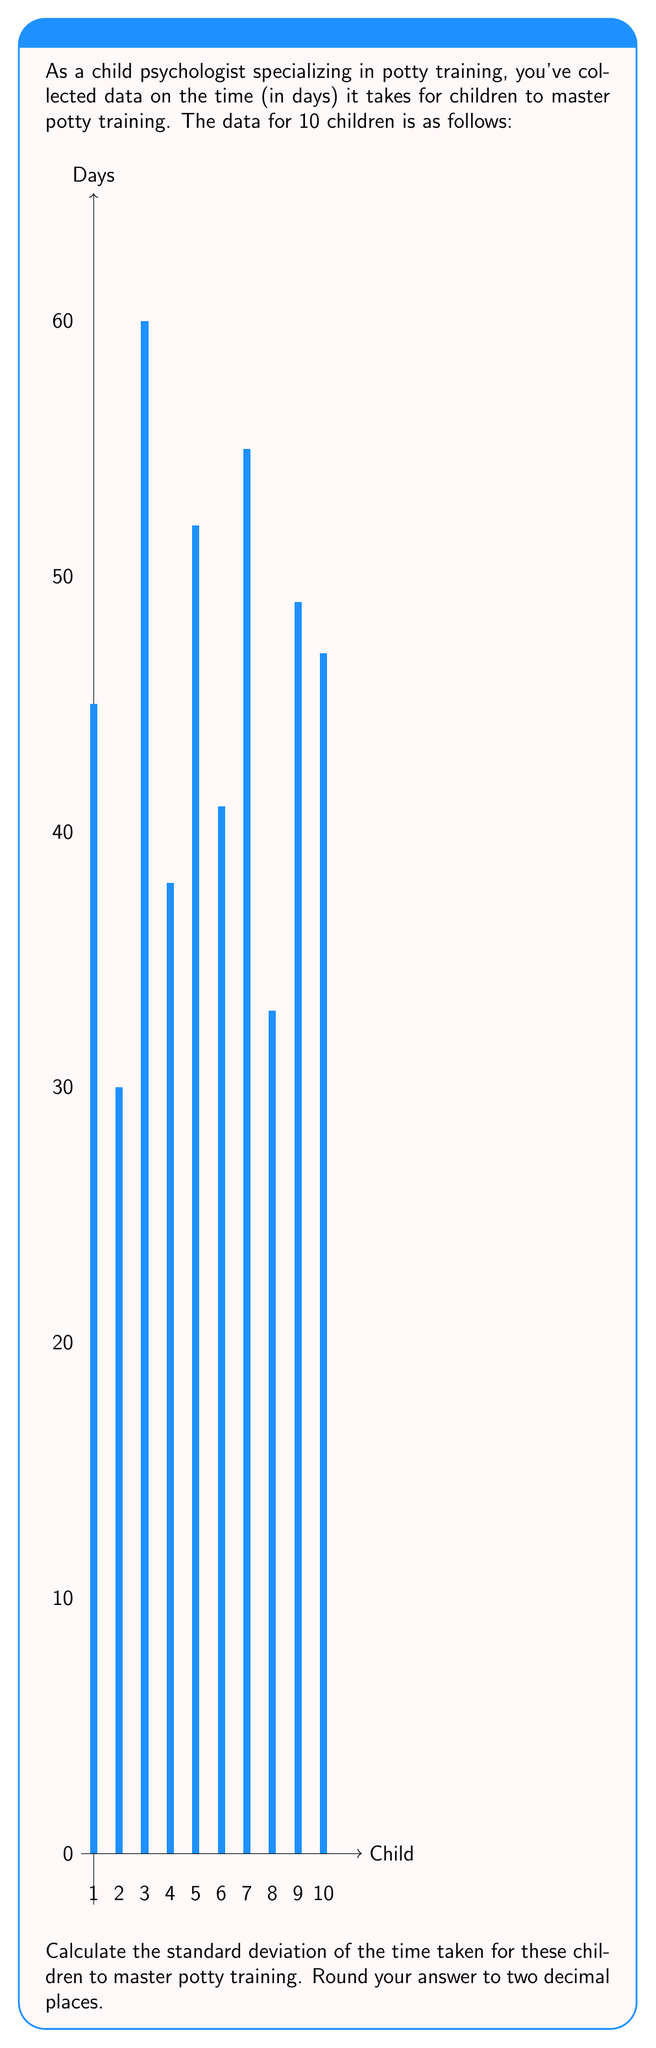Teach me how to tackle this problem. To calculate the standard deviation, we'll follow these steps:

1) First, calculate the mean ($\mu$) of the data:
   $\mu = \frac{45 + 30 + 60 + 38 + 52 + 41 + 55 + 33 + 49 + 47}{10} = 45$ days

2) Calculate the squared differences from the mean:
   $(45-45)^2 = 0$
   $(30-45)^2 = 225$
   $(60-45)^2 = 225$
   $(38-45)^2 = 49$
   $(52-45)^2 = 49$
   $(41-45)^2 = 16$
   $(55-45)^2 = 100$
   $(33-45)^2 = 144$
   $(49-45)^2 = 16$
   $(47-45)^2 = 4$

3) Sum these squared differences:
   $0 + 225 + 225 + 49 + 49 + 16 + 100 + 144 + 16 + 4 = 828$

4) Divide by $(n-1) = 9$ to get the variance:
   $\text{Variance} = \frac{828}{9} = 92$

5) Take the square root to get the standard deviation:
   $\text{Standard Deviation} = \sqrt{92} \approx 9.59$ days

Therefore, the standard deviation of the time taken for these children to master potty training is approximately 9.59 days.
Answer: 9.59 days 